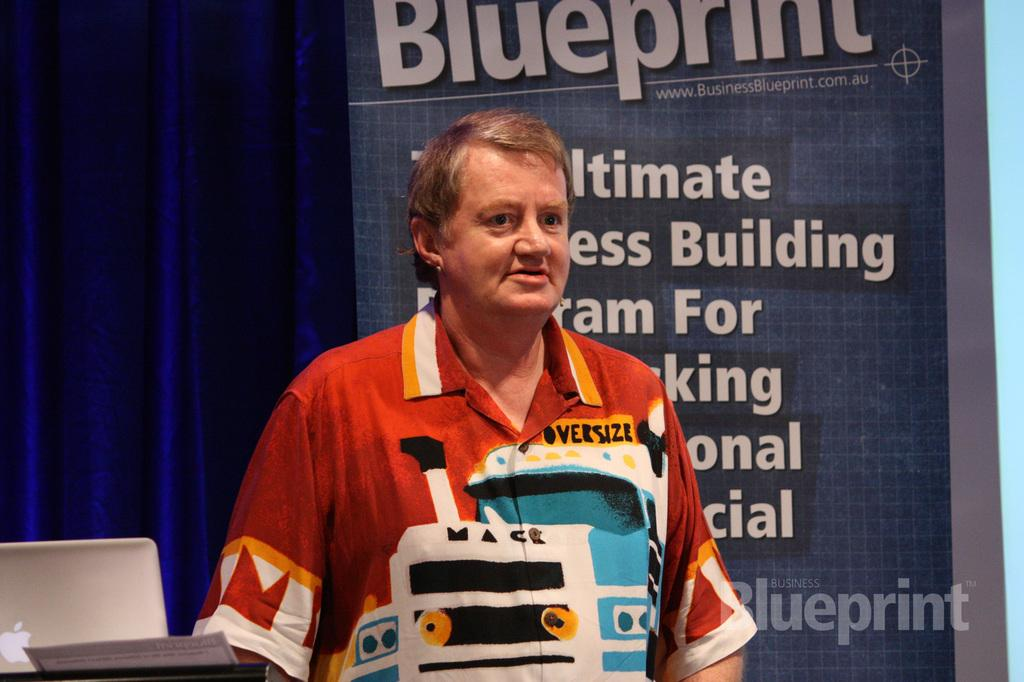<image>
Provide a brief description of the given image. Man standing in front of a sign which says Blueprint. 